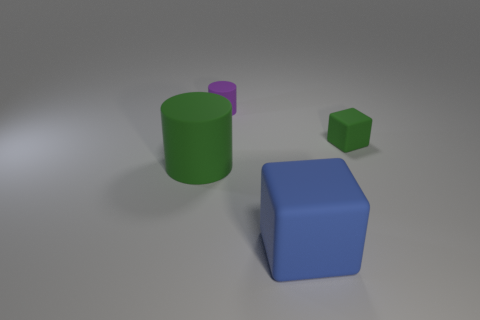Can you tell me about the lighting in the scene? The lighting in the scene is diffuse, suggesting an indoor setting with a source of light that is out of the frame, possibly overhead. This creates soft shadows to the sides and underneath the objects. 